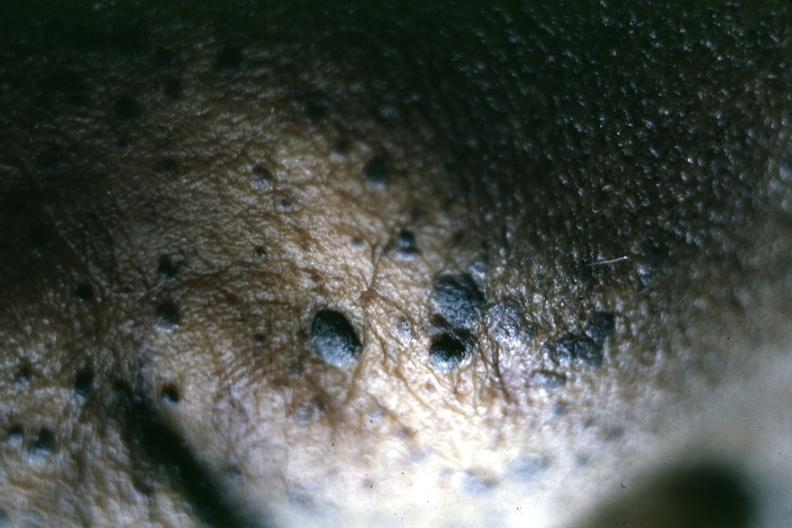does craniopharyngioma show close-up of typical lesions perspective of elevated pasted on lesions is well shown?
Answer the question using a single word or phrase. No 